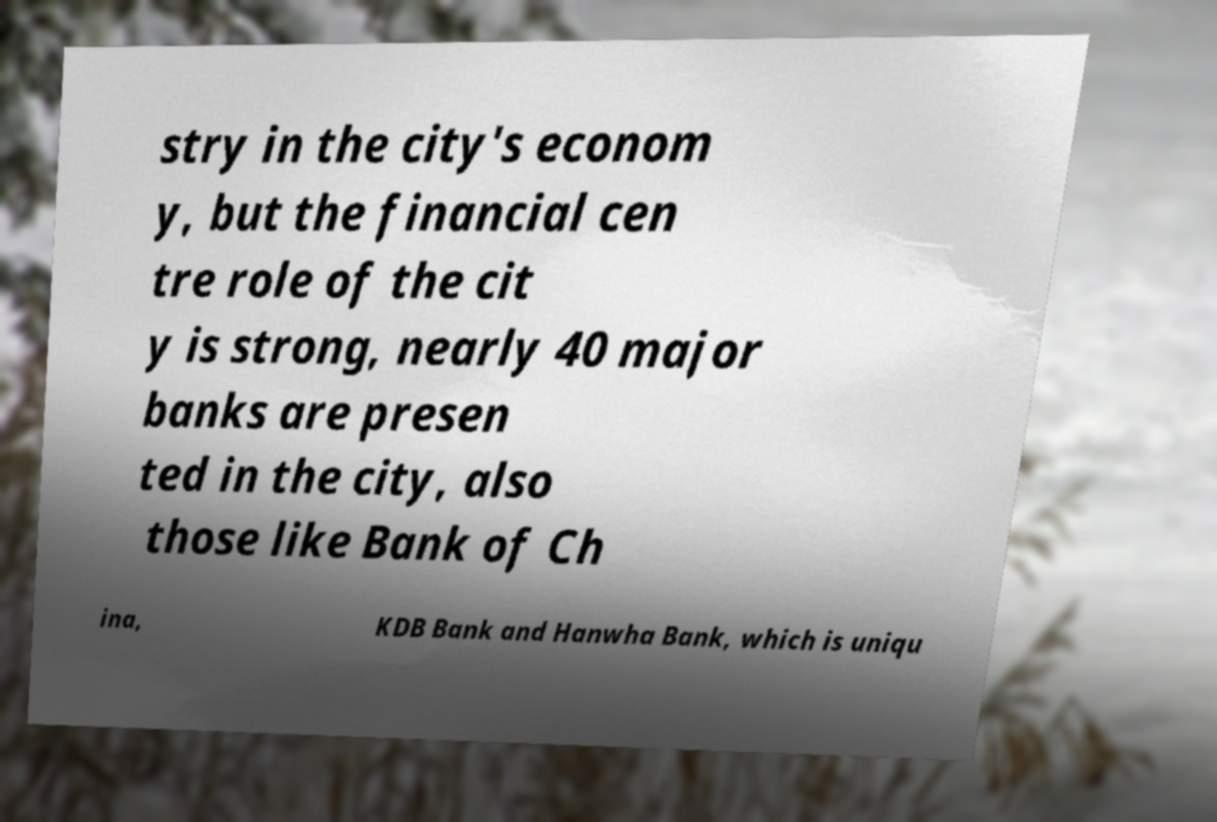Could you assist in decoding the text presented in this image and type it out clearly? stry in the city's econom y, but the financial cen tre role of the cit y is strong, nearly 40 major banks are presen ted in the city, also those like Bank of Ch ina, KDB Bank and Hanwha Bank, which is uniqu 